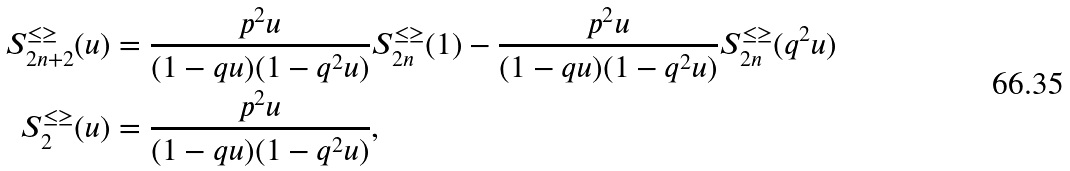<formula> <loc_0><loc_0><loc_500><loc_500>S ^ { \leq \geq } _ { 2 n + 2 } ( u ) & = \frac { p ^ { 2 } u } { ( 1 - q u ) ( 1 - q ^ { 2 } u ) } S ^ { \leq \geq } _ { 2 n } ( 1 ) - \frac { p ^ { 2 } u } { ( 1 - q u ) ( 1 - q ^ { 2 } u ) } S ^ { \leq \geq } _ { 2 n } ( q ^ { 2 } u ) \\ S ^ { \leq \geq } _ { 2 } ( u ) & = \frac { p ^ { 2 } u } { ( 1 - q u ) ( 1 - q ^ { 2 } u ) } ,</formula> 